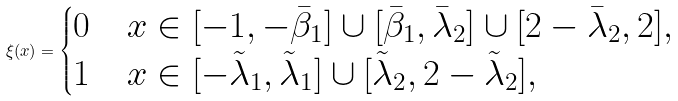<formula> <loc_0><loc_0><loc_500><loc_500>\xi ( x ) = \begin{cases} 0 & x \in [ - 1 , - \bar { \beta } _ { 1 } ] \cup [ \bar { \beta } _ { 1 } , \bar { \lambda } _ { 2 } ] \cup [ 2 - \bar { \lambda } _ { 2 } , 2 ] , \\ 1 & x \in [ - \tilde { \lambda } _ { 1 } , \tilde { \lambda } _ { 1 } ] \cup [ \tilde { \lambda } _ { 2 } , 2 - \tilde { \lambda } _ { 2 } ] , \end{cases}</formula> 